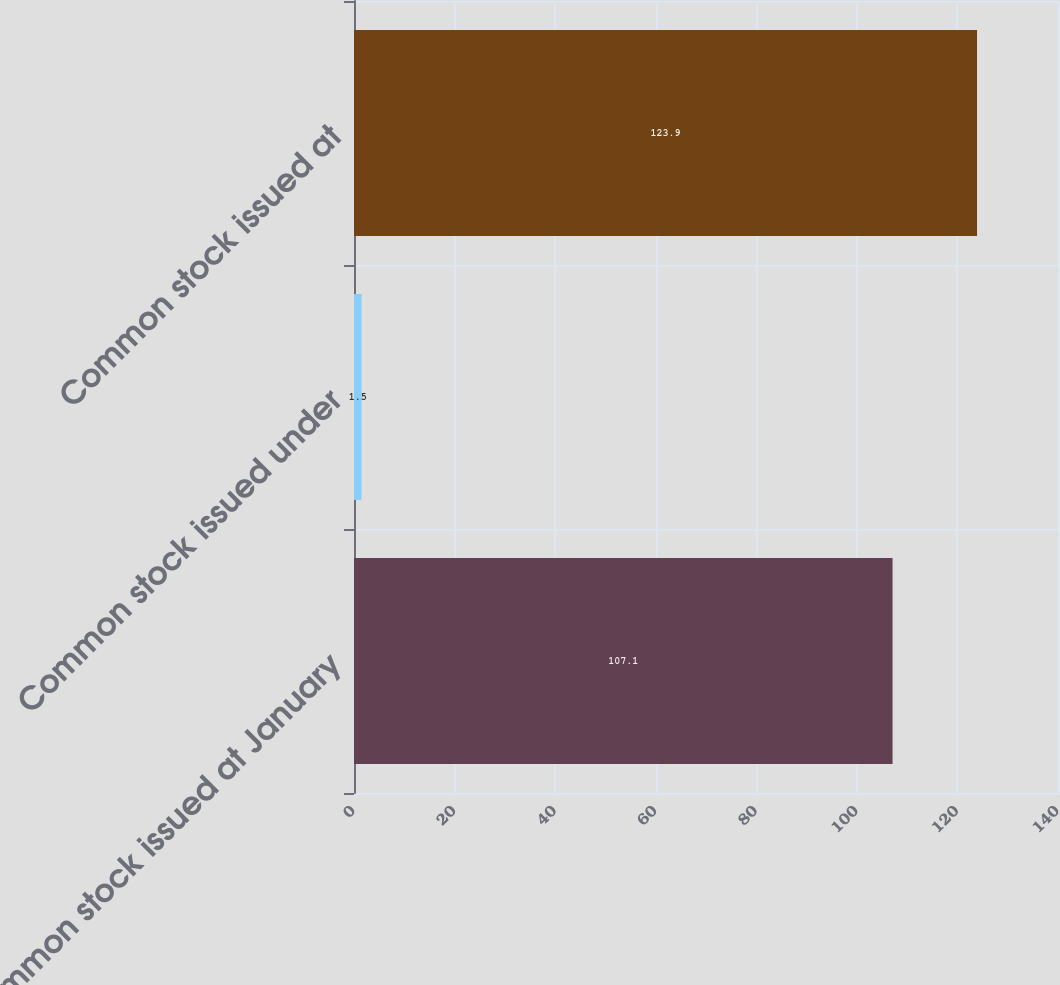<chart> <loc_0><loc_0><loc_500><loc_500><bar_chart><fcel>Common stock issued at January<fcel>Common stock issued under<fcel>Common stock issued at<nl><fcel>107.1<fcel>1.5<fcel>123.9<nl></chart> 